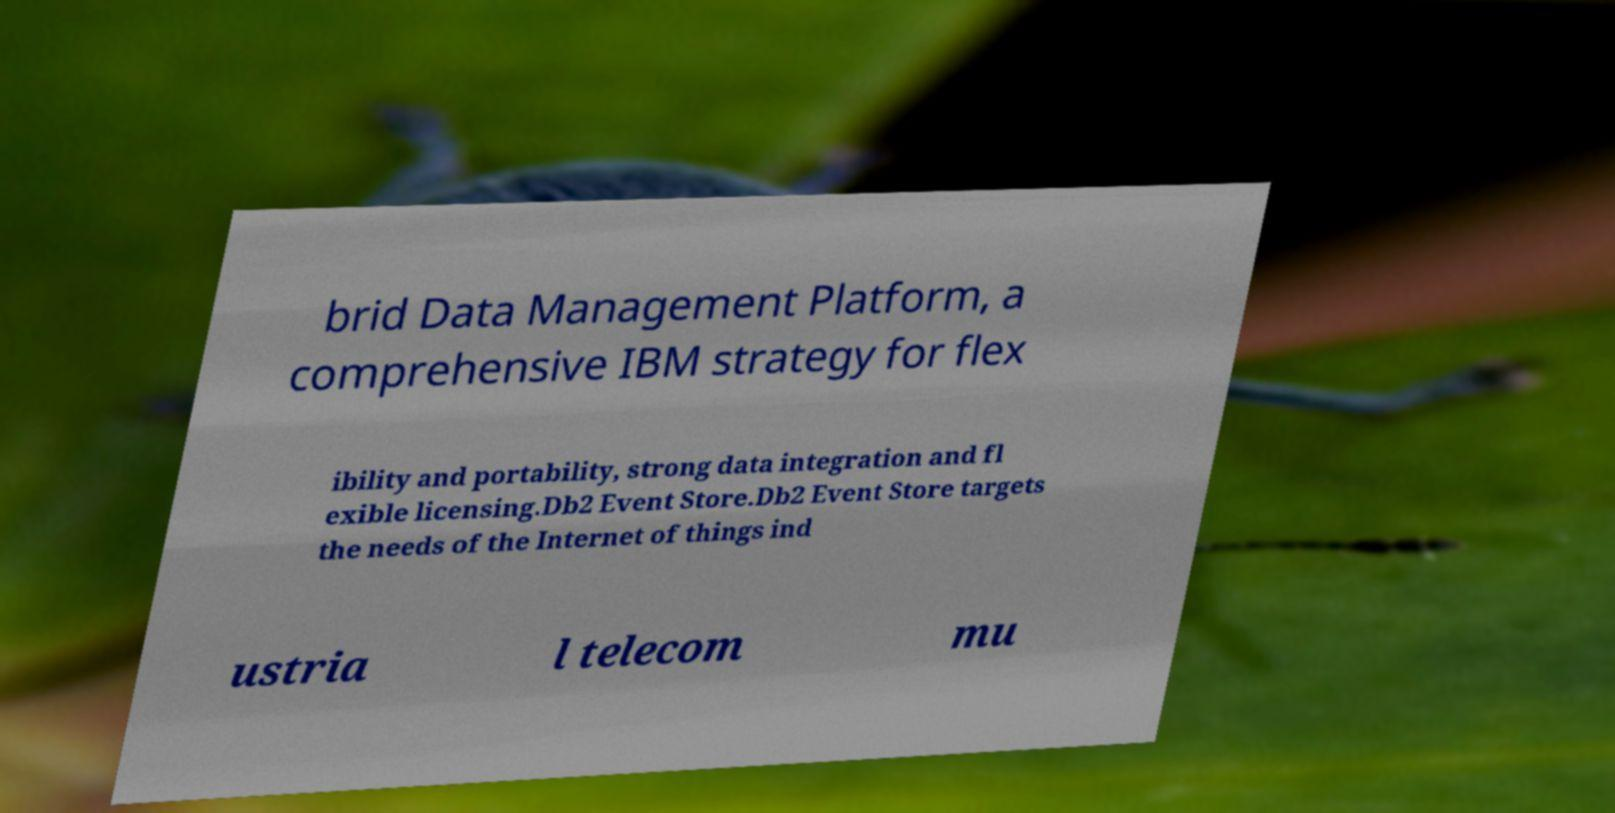Can you read and provide the text displayed in the image?This photo seems to have some interesting text. Can you extract and type it out for me? brid Data Management Platform, a comprehensive IBM strategy for flex ibility and portability, strong data integration and fl exible licensing.Db2 Event Store.Db2 Event Store targets the needs of the Internet of things ind ustria l telecom mu 